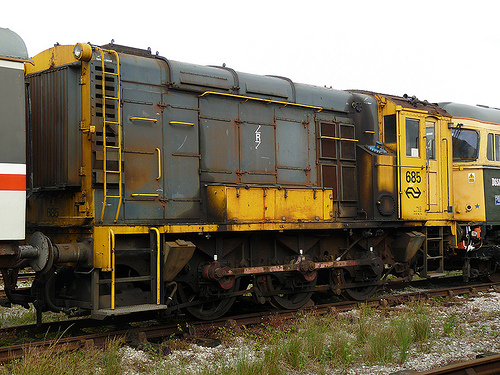What color is the train car that is to the left of the ladder, orange or white? The train car to the left of the ladder is orange. 